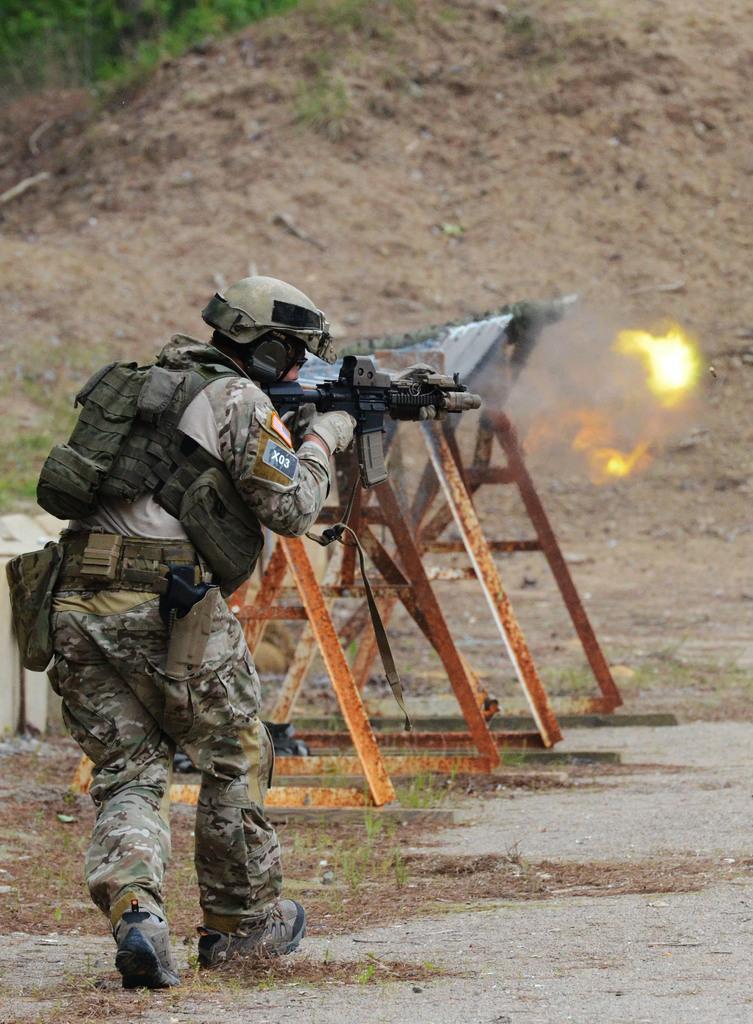Please provide a concise description of this image. In the center of the image we can see person running on the ground holding a gun. In the background we can see equipment, grass and ground. 